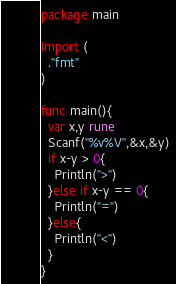Convert code to text. <code><loc_0><loc_0><loc_500><loc_500><_Go_>package main

import (
  ."fmt"
)

func main(){
  var x,y rune
  Scanf("%v%V",&x,&y)
  if x-y > 0{
    Println(">")
  }else if x-y == 0{
    Println("=")
  }else{
    Println("<")
  }
}
</code> 